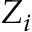Convert formula to latex. <formula><loc_0><loc_0><loc_500><loc_500>Z _ { i }</formula> 